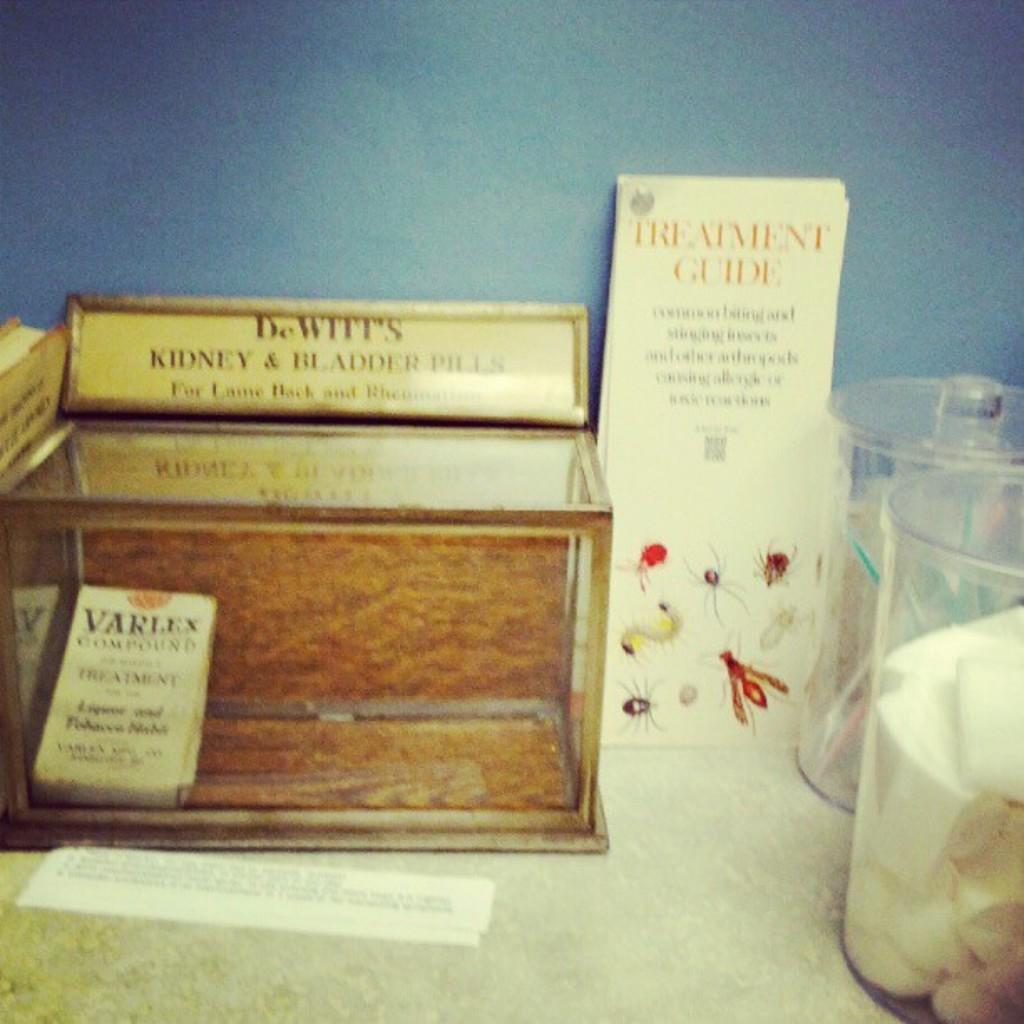Provide a one-sentence caption for the provided image. A wooden and glass box sits on a counter with a name plate for DeWitt's Kidney and Bladder Pills sitting on top of the box. 